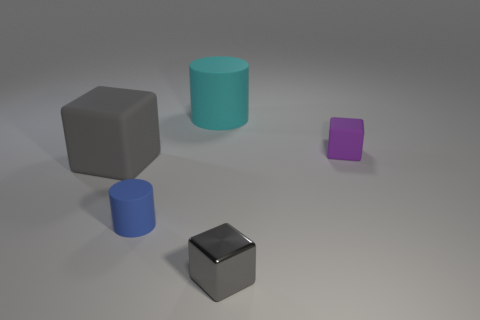Add 3 large matte objects. How many objects exist? 8 Subtract all cubes. How many objects are left? 2 Subtract 0 gray balls. How many objects are left? 5 Subtract all tiny blue cubes. Subtract all large objects. How many objects are left? 3 Add 5 big rubber cubes. How many big rubber cubes are left? 6 Add 5 small blue cylinders. How many small blue cylinders exist? 6 